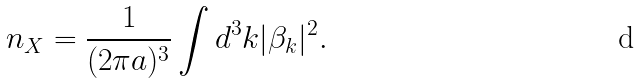<formula> <loc_0><loc_0><loc_500><loc_500>n _ { X } = \frac { 1 } { ( 2 \pi a ) ^ { 3 } } \int d ^ { 3 } k | \beta _ { k } | ^ { 2 } .</formula> 